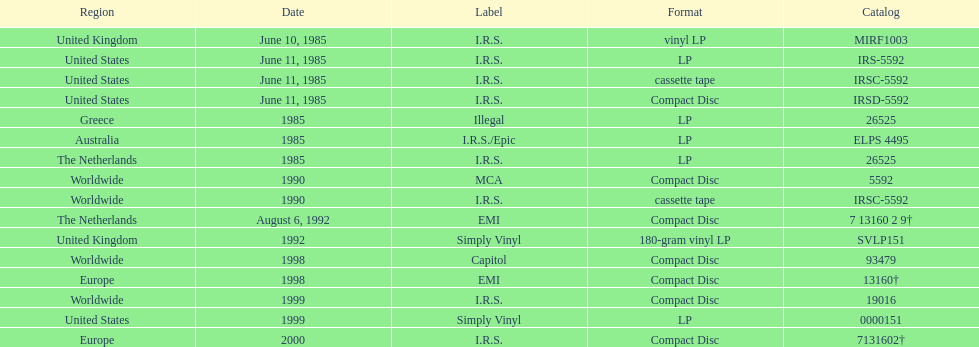Which is the only region with vinyl lp format? United Kingdom. 